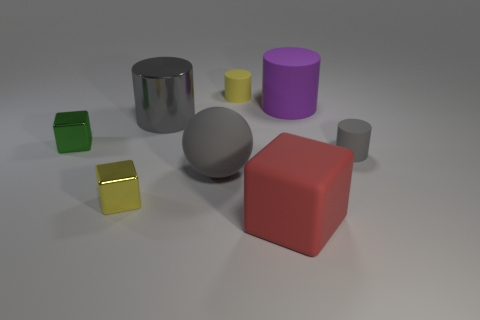Add 1 large gray metal objects. How many objects exist? 9 Subtract all cubes. How many objects are left? 5 Add 5 small gray matte things. How many small gray matte things exist? 6 Subtract 0 blue cylinders. How many objects are left? 8 Subtract all tiny blue cylinders. Subtract all tiny yellow shiny things. How many objects are left? 7 Add 2 gray things. How many gray things are left? 5 